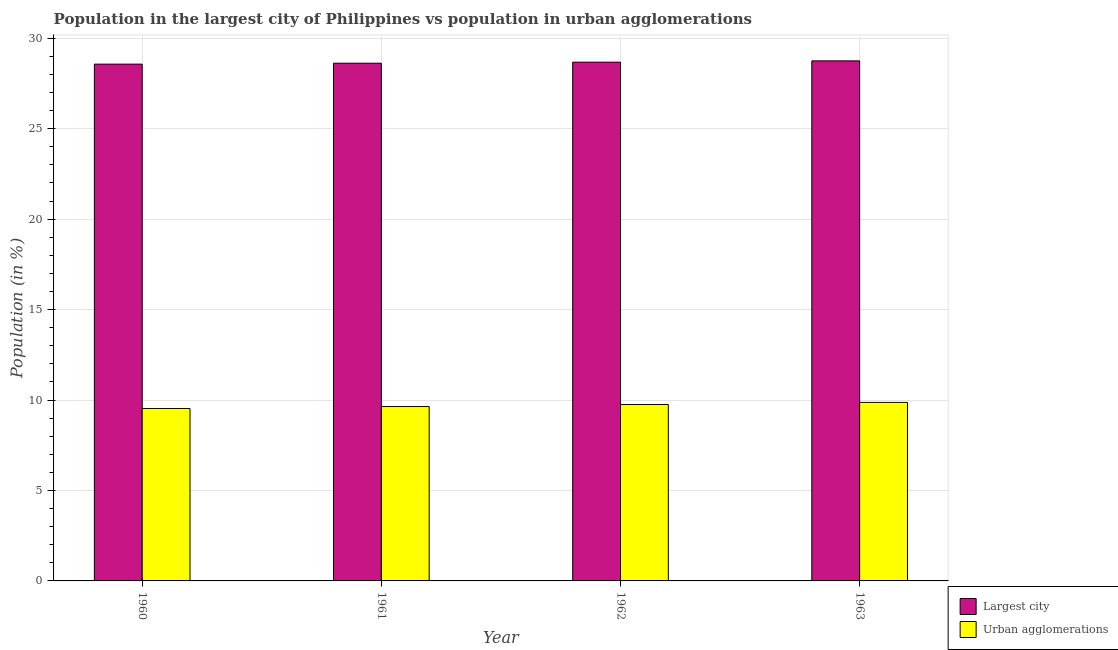How many different coloured bars are there?
Make the answer very short. 2. How many groups of bars are there?
Provide a short and direct response. 4. Are the number of bars on each tick of the X-axis equal?
Offer a very short reply. Yes. How many bars are there on the 2nd tick from the left?
Make the answer very short. 2. How many bars are there on the 2nd tick from the right?
Your response must be concise. 2. What is the label of the 3rd group of bars from the left?
Provide a succinct answer. 1962. In how many cases, is the number of bars for a given year not equal to the number of legend labels?
Keep it short and to the point. 0. What is the population in the largest city in 1963?
Offer a terse response. 28.75. Across all years, what is the maximum population in the largest city?
Provide a short and direct response. 28.75. Across all years, what is the minimum population in the largest city?
Keep it short and to the point. 28.56. In which year was the population in the largest city minimum?
Offer a very short reply. 1960. What is the total population in the largest city in the graph?
Your answer should be compact. 114.6. What is the difference between the population in the largest city in 1961 and that in 1963?
Your answer should be very brief. -0.13. What is the difference between the population in the largest city in 1963 and the population in urban agglomerations in 1962?
Make the answer very short. 0.07. What is the average population in the largest city per year?
Keep it short and to the point. 28.65. What is the ratio of the population in the largest city in 1960 to that in 1963?
Your answer should be compact. 0.99. Is the population in the largest city in 1961 less than that in 1962?
Give a very brief answer. Yes. Is the difference between the population in the largest city in 1960 and 1963 greater than the difference between the population in urban agglomerations in 1960 and 1963?
Provide a succinct answer. No. What is the difference between the highest and the second highest population in urban agglomerations?
Your answer should be very brief. 0.12. What is the difference between the highest and the lowest population in urban agglomerations?
Offer a terse response. 0.34. In how many years, is the population in urban agglomerations greater than the average population in urban agglomerations taken over all years?
Ensure brevity in your answer.  2. Is the sum of the population in urban agglomerations in 1960 and 1961 greater than the maximum population in the largest city across all years?
Your answer should be compact. Yes. What does the 1st bar from the left in 1962 represents?
Your response must be concise. Largest city. What does the 2nd bar from the right in 1960 represents?
Your answer should be compact. Largest city. Are all the bars in the graph horizontal?
Keep it short and to the point. No. How many years are there in the graph?
Your response must be concise. 4. Are the values on the major ticks of Y-axis written in scientific E-notation?
Your response must be concise. No. Where does the legend appear in the graph?
Offer a terse response. Bottom right. What is the title of the graph?
Give a very brief answer. Population in the largest city of Philippines vs population in urban agglomerations. What is the label or title of the X-axis?
Keep it short and to the point. Year. What is the Population (in %) in Largest city in 1960?
Your response must be concise. 28.56. What is the Population (in %) of Urban agglomerations in 1960?
Ensure brevity in your answer.  9.53. What is the Population (in %) in Largest city in 1961?
Ensure brevity in your answer.  28.62. What is the Population (in %) in Urban agglomerations in 1961?
Provide a short and direct response. 9.64. What is the Population (in %) in Largest city in 1962?
Keep it short and to the point. 28.67. What is the Population (in %) of Urban agglomerations in 1962?
Ensure brevity in your answer.  9.75. What is the Population (in %) in Largest city in 1963?
Offer a terse response. 28.75. What is the Population (in %) of Urban agglomerations in 1963?
Your response must be concise. 9.87. Across all years, what is the maximum Population (in %) of Largest city?
Your answer should be compact. 28.75. Across all years, what is the maximum Population (in %) in Urban agglomerations?
Your answer should be compact. 9.87. Across all years, what is the minimum Population (in %) in Largest city?
Keep it short and to the point. 28.56. Across all years, what is the minimum Population (in %) of Urban agglomerations?
Your answer should be very brief. 9.53. What is the total Population (in %) of Largest city in the graph?
Keep it short and to the point. 114.6. What is the total Population (in %) in Urban agglomerations in the graph?
Offer a terse response. 38.79. What is the difference between the Population (in %) of Largest city in 1960 and that in 1961?
Offer a terse response. -0.05. What is the difference between the Population (in %) in Urban agglomerations in 1960 and that in 1961?
Your answer should be compact. -0.11. What is the difference between the Population (in %) in Largest city in 1960 and that in 1962?
Offer a very short reply. -0.11. What is the difference between the Population (in %) in Urban agglomerations in 1960 and that in 1962?
Give a very brief answer. -0.22. What is the difference between the Population (in %) in Largest city in 1960 and that in 1963?
Give a very brief answer. -0.18. What is the difference between the Population (in %) in Urban agglomerations in 1960 and that in 1963?
Offer a very short reply. -0.34. What is the difference between the Population (in %) in Largest city in 1961 and that in 1962?
Offer a very short reply. -0.06. What is the difference between the Population (in %) in Urban agglomerations in 1961 and that in 1962?
Provide a short and direct response. -0.11. What is the difference between the Population (in %) of Largest city in 1961 and that in 1963?
Provide a succinct answer. -0.13. What is the difference between the Population (in %) in Urban agglomerations in 1961 and that in 1963?
Your answer should be very brief. -0.23. What is the difference between the Population (in %) in Largest city in 1962 and that in 1963?
Offer a very short reply. -0.07. What is the difference between the Population (in %) in Urban agglomerations in 1962 and that in 1963?
Your answer should be very brief. -0.12. What is the difference between the Population (in %) in Largest city in 1960 and the Population (in %) in Urban agglomerations in 1961?
Make the answer very short. 18.93. What is the difference between the Population (in %) of Largest city in 1960 and the Population (in %) of Urban agglomerations in 1962?
Ensure brevity in your answer.  18.81. What is the difference between the Population (in %) of Largest city in 1960 and the Population (in %) of Urban agglomerations in 1963?
Your answer should be very brief. 18.7. What is the difference between the Population (in %) of Largest city in 1961 and the Population (in %) of Urban agglomerations in 1962?
Provide a short and direct response. 18.87. What is the difference between the Population (in %) in Largest city in 1961 and the Population (in %) in Urban agglomerations in 1963?
Keep it short and to the point. 18.75. What is the difference between the Population (in %) in Largest city in 1962 and the Population (in %) in Urban agglomerations in 1963?
Your answer should be very brief. 18.81. What is the average Population (in %) in Largest city per year?
Your answer should be very brief. 28.65. What is the average Population (in %) in Urban agglomerations per year?
Keep it short and to the point. 9.7. In the year 1960, what is the difference between the Population (in %) in Largest city and Population (in %) in Urban agglomerations?
Your response must be concise. 19.03. In the year 1961, what is the difference between the Population (in %) of Largest city and Population (in %) of Urban agglomerations?
Give a very brief answer. 18.98. In the year 1962, what is the difference between the Population (in %) in Largest city and Population (in %) in Urban agglomerations?
Offer a terse response. 18.92. In the year 1963, what is the difference between the Population (in %) in Largest city and Population (in %) in Urban agglomerations?
Offer a terse response. 18.88. What is the ratio of the Population (in %) in Urban agglomerations in 1960 to that in 1961?
Provide a succinct answer. 0.99. What is the ratio of the Population (in %) in Urban agglomerations in 1960 to that in 1962?
Your response must be concise. 0.98. What is the ratio of the Population (in %) in Urban agglomerations in 1960 to that in 1963?
Give a very brief answer. 0.97. What is the ratio of the Population (in %) in Largest city in 1961 to that in 1963?
Your response must be concise. 1. What is the ratio of the Population (in %) of Urban agglomerations in 1961 to that in 1963?
Your answer should be compact. 0.98. What is the difference between the highest and the second highest Population (in %) of Largest city?
Ensure brevity in your answer.  0.07. What is the difference between the highest and the second highest Population (in %) of Urban agglomerations?
Your response must be concise. 0.12. What is the difference between the highest and the lowest Population (in %) of Largest city?
Ensure brevity in your answer.  0.18. What is the difference between the highest and the lowest Population (in %) of Urban agglomerations?
Provide a short and direct response. 0.34. 